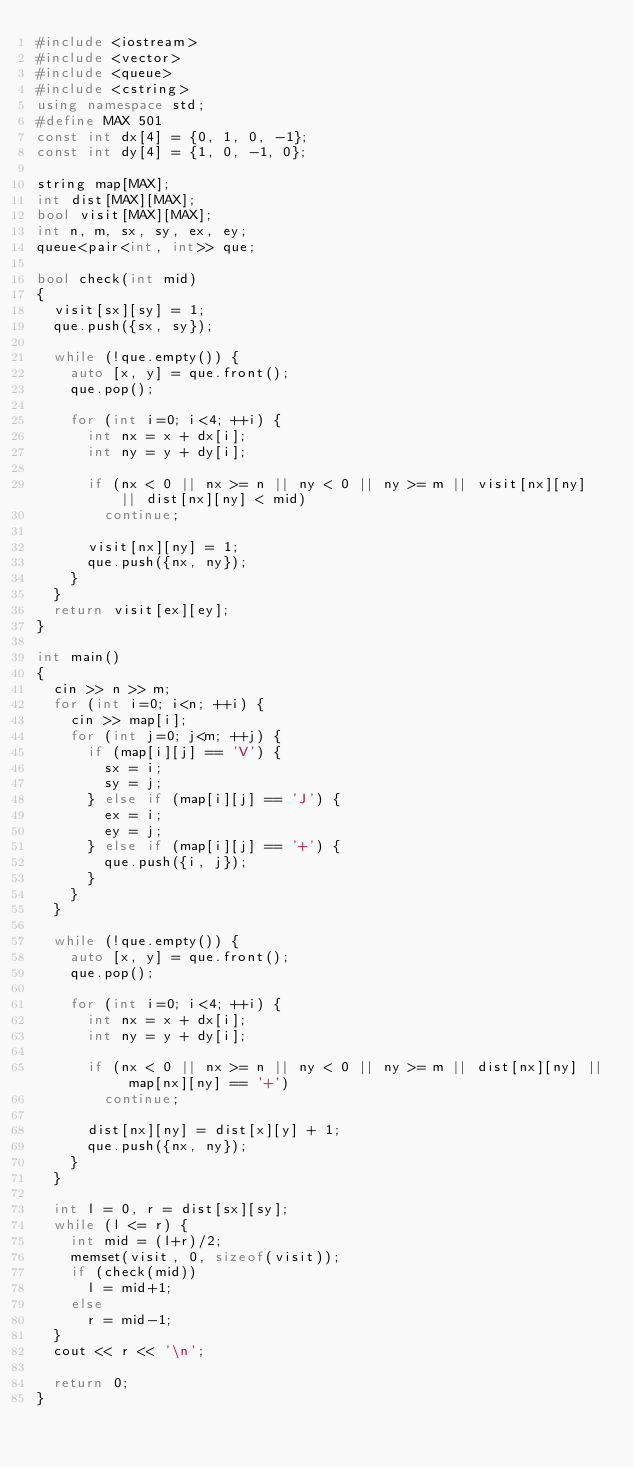Convert code to text. <code><loc_0><loc_0><loc_500><loc_500><_C++_>#include <iostream>
#include <vector>
#include <queue>
#include <cstring>
using namespace std;
#define MAX 501
const int dx[4] = {0, 1, 0, -1};
const int dy[4] = {1, 0, -1, 0};

string map[MAX];
int dist[MAX][MAX];
bool visit[MAX][MAX];
int n, m, sx, sy, ex, ey;
queue<pair<int, int>> que;

bool check(int mid)
{
	visit[sx][sy] = 1;
	que.push({sx, sy});

	while (!que.empty()) {
		auto [x, y] = que.front();
		que.pop();

		for (int i=0; i<4; ++i) {
			int nx = x + dx[i];
			int ny = y + dy[i];

			if (nx < 0 || nx >= n || ny < 0 || ny >= m || visit[nx][ny] || dist[nx][ny] < mid)
				continue;

			visit[nx][ny] = 1;
			que.push({nx, ny});
		}
	}
	return visit[ex][ey];
}

int main()
{
	cin >> n >> m;
	for (int i=0; i<n; ++i) {
		cin >> map[i];
		for (int j=0; j<m; ++j) {
			if (map[i][j] == 'V') {
				sx = i;
				sy = j;
			} else if (map[i][j] == 'J') {
				ex = i;
				ey = j;
			} else if (map[i][j] == '+') {
				que.push({i, j});
			}
		}
	}

	while (!que.empty()) {
		auto [x, y] = que.front();
		que.pop();

		for (int i=0; i<4; ++i) {
			int nx = x + dx[i];
			int ny = y + dy[i];

			if (nx < 0 || nx >= n || ny < 0 || ny >= m || dist[nx][ny] || map[nx][ny] == '+')
				continue;

			dist[nx][ny] = dist[x][y] + 1;
			que.push({nx, ny});
		}
	}

	int l = 0, r = dist[sx][sy];
	while (l <= r) {
		int mid = (l+r)/2;
		memset(visit, 0, sizeof(visit));
		if (check(mid))
			l = mid+1;
		else
			r = mid-1;
	}
	cout << r << '\n';

	return 0;
}
</code> 